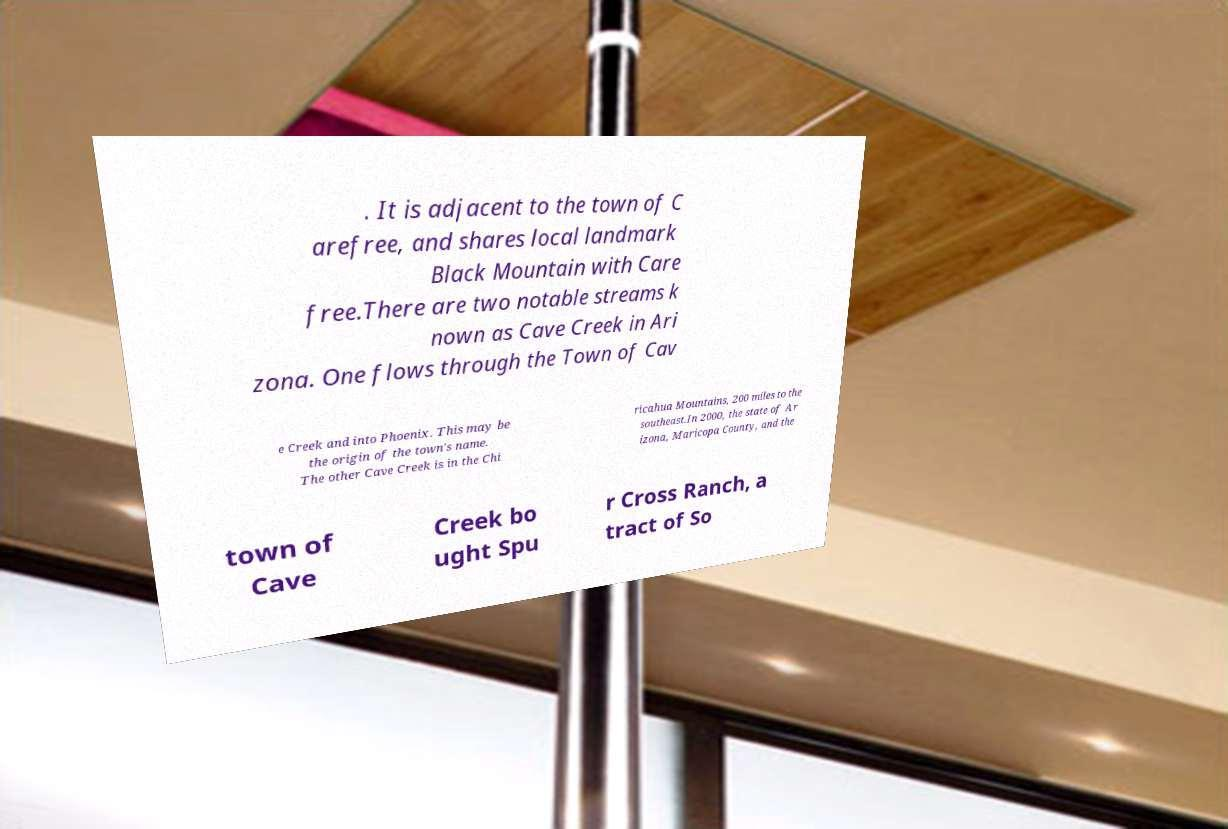Could you extract and type out the text from this image? . It is adjacent to the town of C arefree, and shares local landmark Black Mountain with Care free.There are two notable streams k nown as Cave Creek in Ari zona. One flows through the Town of Cav e Creek and into Phoenix. This may be the origin of the town's name. The other Cave Creek is in the Chi ricahua Mountains, 200 miles to the southeast.In 2000, the state of Ar izona, Maricopa County, and the town of Cave Creek bo ught Spu r Cross Ranch, a tract of So 